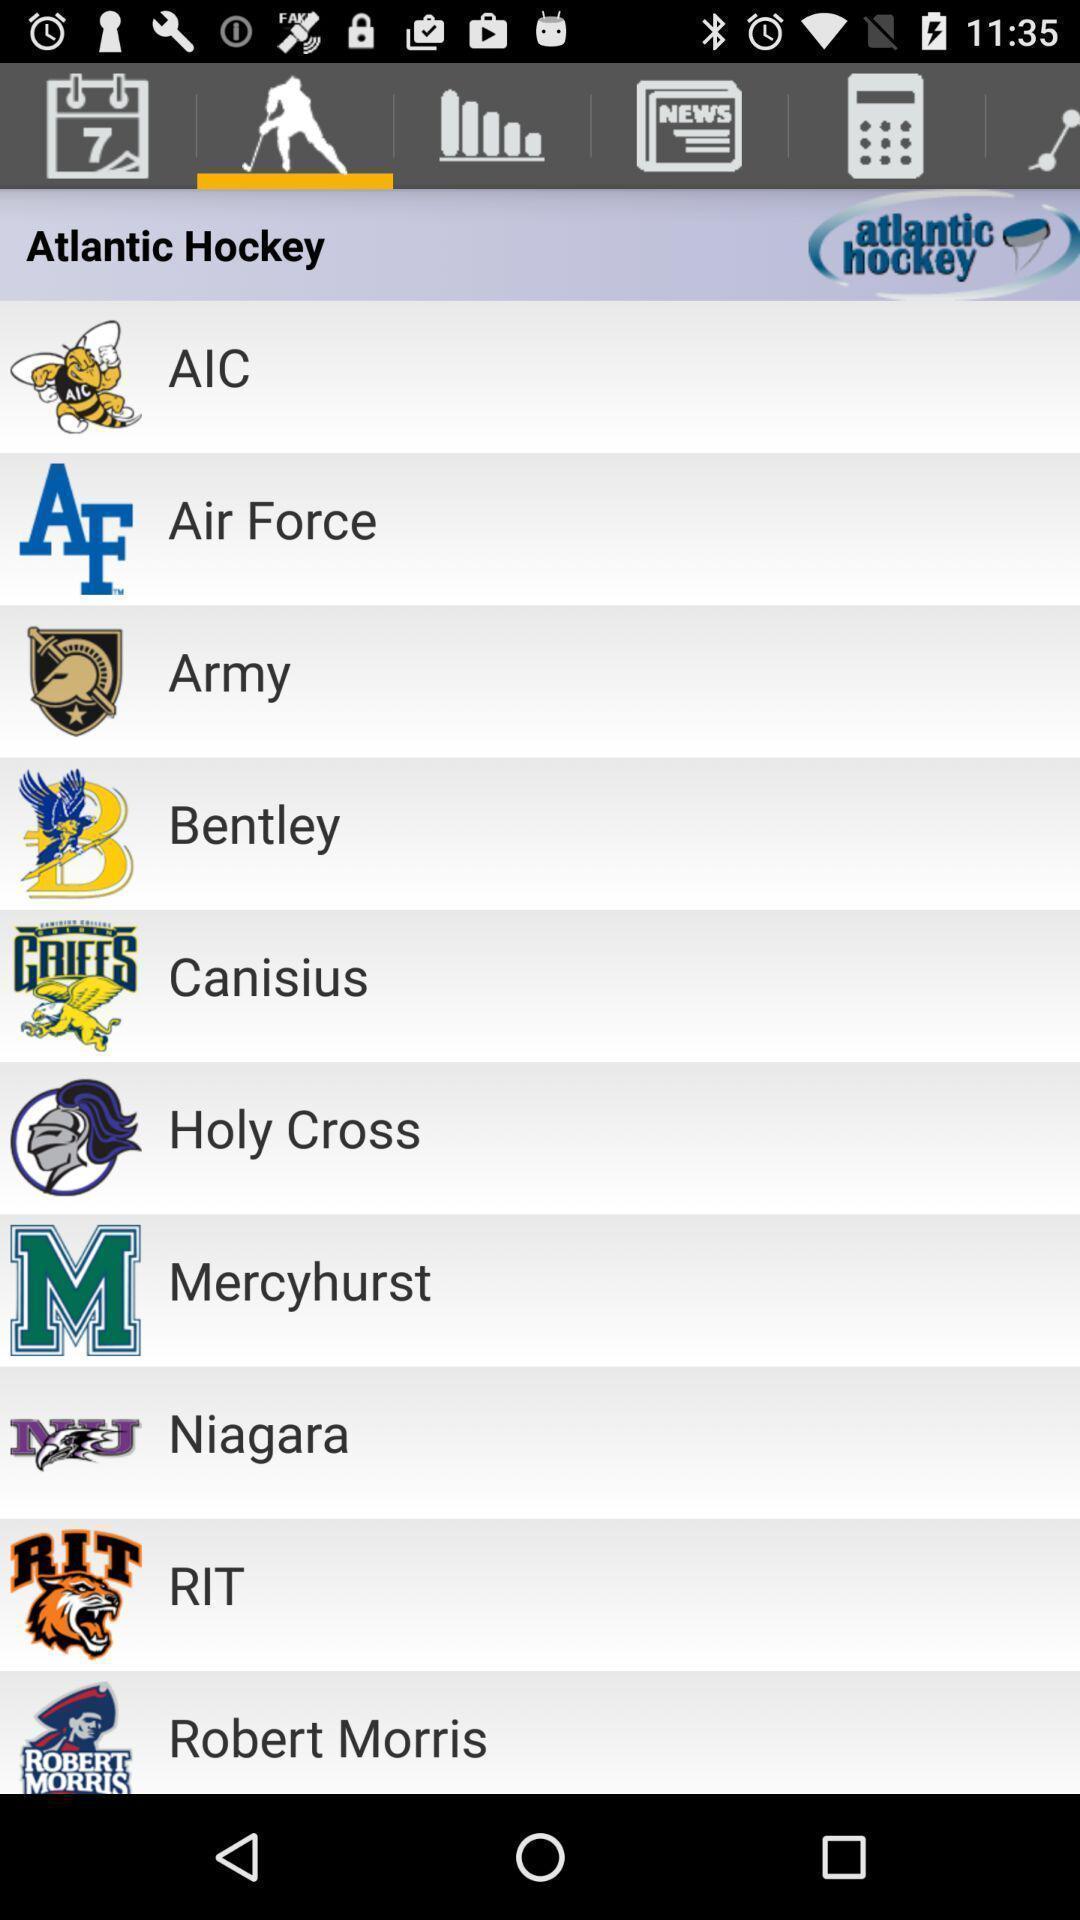Give me a summary of this screen capture. Screen page of sports application. 